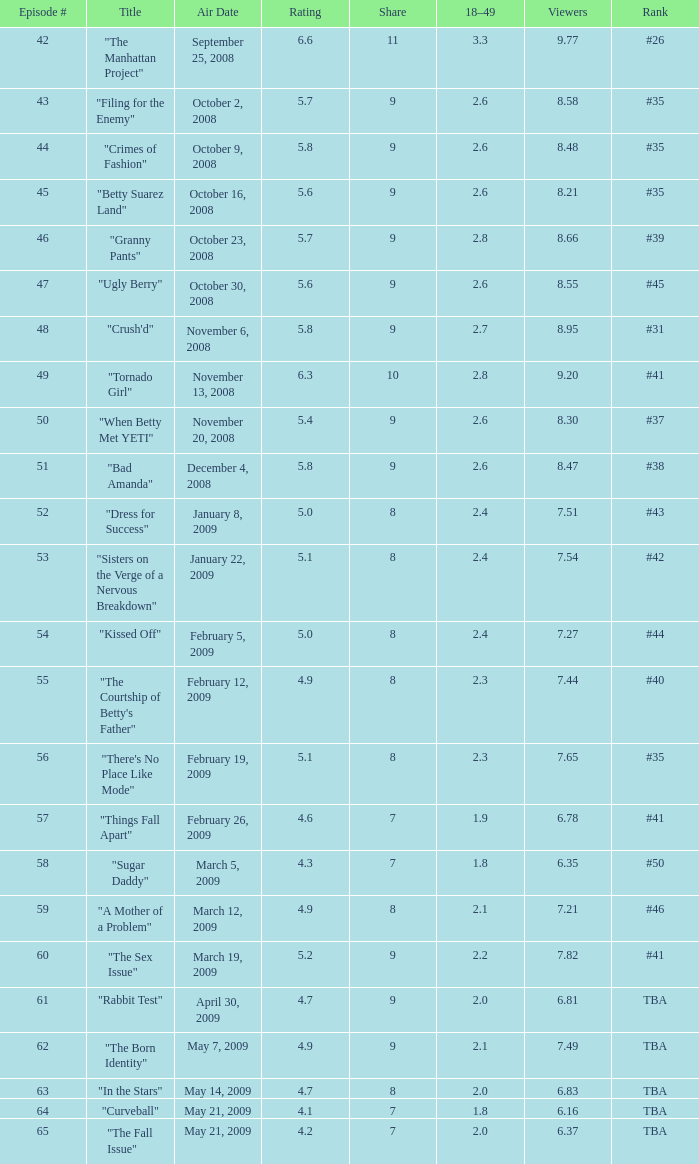What is the mean episode number with a share of 9, and rank #35 having fewer than None. 